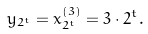<formula> <loc_0><loc_0><loc_500><loc_500>y _ { 2 ^ { t } } = x _ { 2 ^ { t } } ^ { ( 3 ) } = 3 \cdot 2 ^ { t } .</formula> 